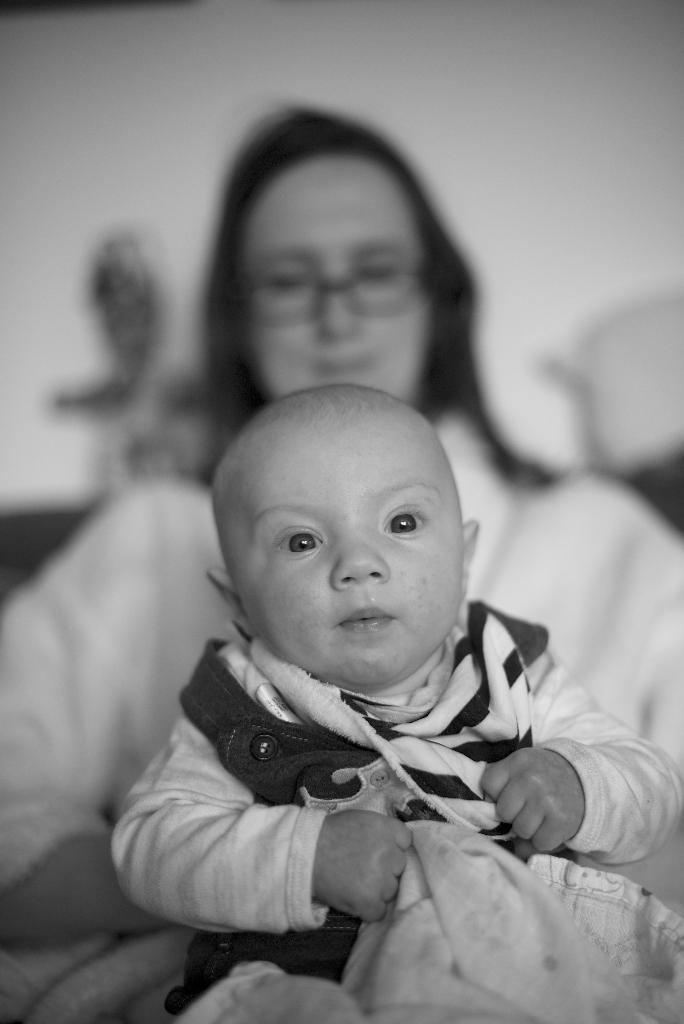Who is in the picture with the baby? The baby is sitting with a woman. What is the woman wearing in the picture? The woman is wearing a white dress. What is the baby holding in the picture? The baby is holding some cloth. What can be seen in the background of the picture? There is a wall in the background of the picture. What type of health advice is the woman giving to the baby in the picture? There is no indication in the image that the woman is giving any health advice to the baby. 